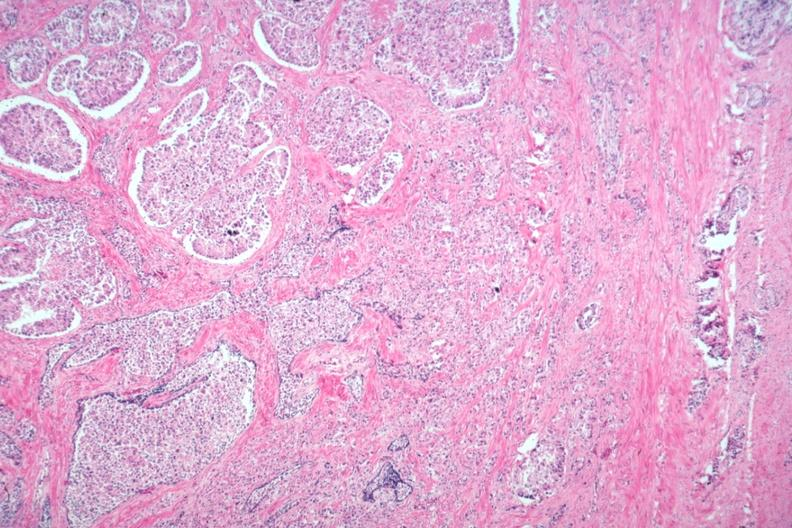what is present?
Answer the question using a single word or phrase. Prostate 